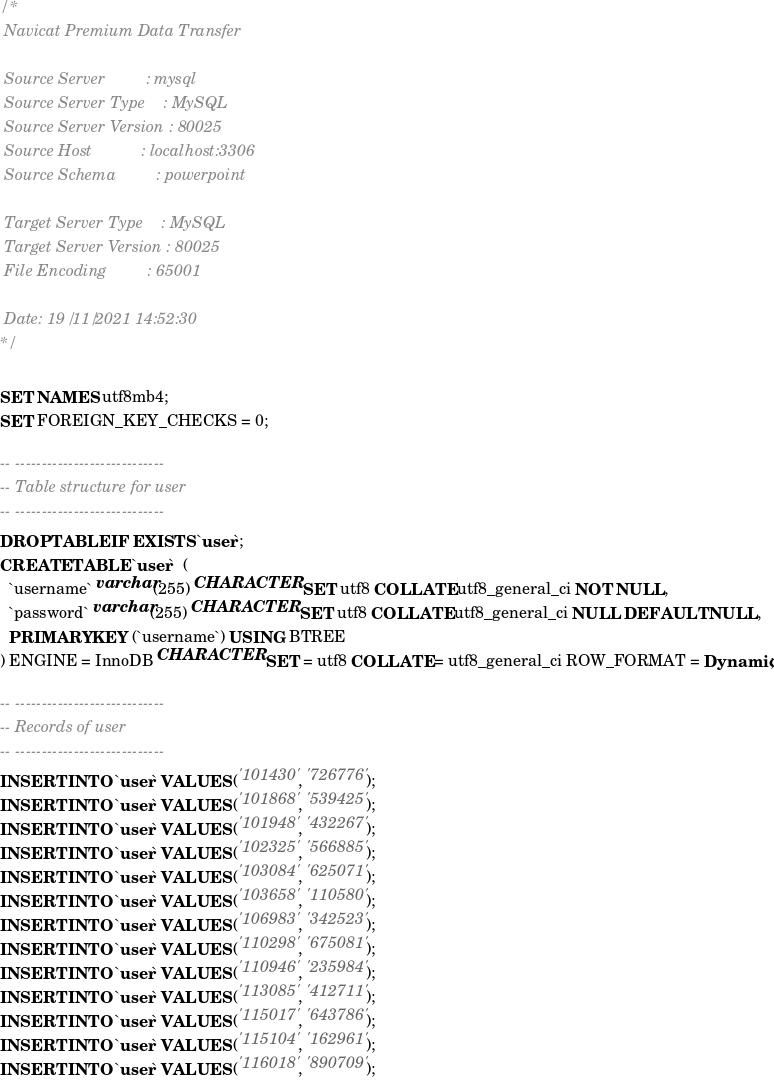<code> <loc_0><loc_0><loc_500><loc_500><_SQL_>/*
 Navicat Premium Data Transfer

 Source Server         : mysql
 Source Server Type    : MySQL
 Source Server Version : 80025
 Source Host           : localhost:3306
 Source Schema         : powerpoint

 Target Server Type    : MySQL
 Target Server Version : 80025
 File Encoding         : 65001

 Date: 19/11/2021 14:52:30
*/

SET NAMES utf8mb4;
SET FOREIGN_KEY_CHECKS = 0;

-- ----------------------------
-- Table structure for user
-- ----------------------------
DROP TABLE IF EXISTS `user`;
CREATE TABLE `user`  (
  `username` varchar(255) CHARACTER SET utf8 COLLATE utf8_general_ci NOT NULL,
  `password` varchar(255) CHARACTER SET utf8 COLLATE utf8_general_ci NULL DEFAULT NULL,
  PRIMARY KEY (`username`) USING BTREE
) ENGINE = InnoDB CHARACTER SET = utf8 COLLATE = utf8_general_ci ROW_FORMAT = Dynamic;

-- ----------------------------
-- Records of user
-- ----------------------------
INSERT INTO `user` VALUES ('101430', '726776');
INSERT INTO `user` VALUES ('101868', '539425');
INSERT INTO `user` VALUES ('101948', '432267');
INSERT INTO `user` VALUES ('102325', '566885');
INSERT INTO `user` VALUES ('103084', '625071');
INSERT INTO `user` VALUES ('103658', '110580');
INSERT INTO `user` VALUES ('106983', '342523');
INSERT INTO `user` VALUES ('110298', '675081');
INSERT INTO `user` VALUES ('110946', '235984');
INSERT INTO `user` VALUES ('113085', '412711');
INSERT INTO `user` VALUES ('115017', '643786');
INSERT INTO `user` VALUES ('115104', '162961');
INSERT INTO `user` VALUES ('116018', '890709');</code> 